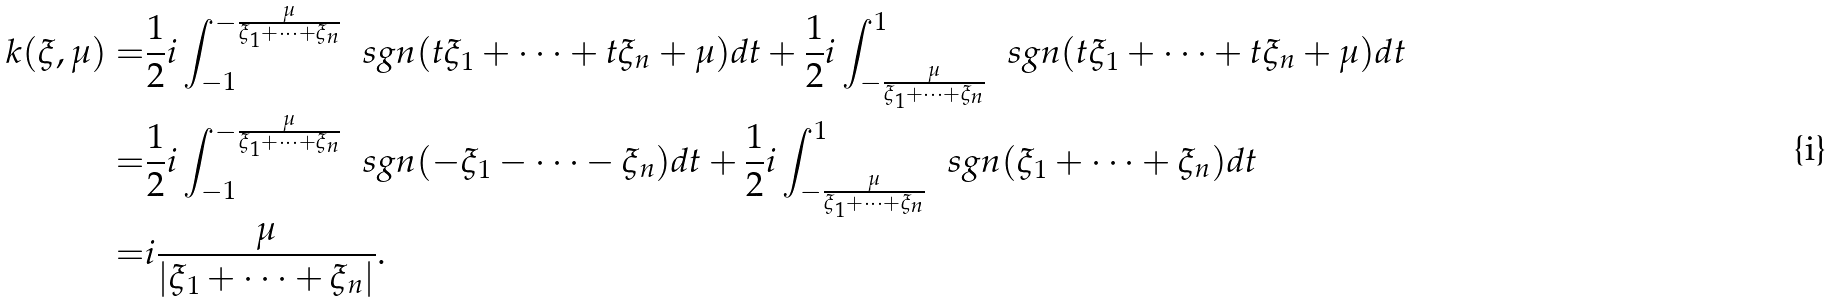Convert formula to latex. <formula><loc_0><loc_0><loc_500><loc_500>k ( \xi , \mu ) = & \frac { 1 } { 2 } i \int _ { - 1 } ^ { - \frac { \mu } { \xi _ { 1 } + \dots + \xi _ { n } } } \, \ s g n ( t \xi _ { 1 } + \dots + t \xi _ { n } + \mu ) d t + \frac { 1 } { 2 } i \int ^ { 1 } _ { - \frac { \mu } { \xi _ { 1 } + \dots + \xi _ { n } } } \, \ s g n ( t \xi _ { 1 } + \dots + t \xi _ { n } + \mu ) d t \\ = & \frac { 1 } { 2 } i \int _ { - 1 } ^ { - \frac { \mu } { \xi _ { 1 } + \dots + \xi _ { n } } } \, \ s g n ( - \xi _ { 1 } - \dots - \xi _ { n } ) d t + \frac { 1 } { 2 } i \int ^ { 1 } _ { - \frac { \mu } { \xi _ { 1 } + \dots + \xi _ { n } } } \, \ s g n ( \xi _ { 1 } + \dots + \xi _ { n } ) d t \\ = & i \frac { \mu } { | \xi _ { 1 } + \dots + \xi _ { n } | } .</formula> 